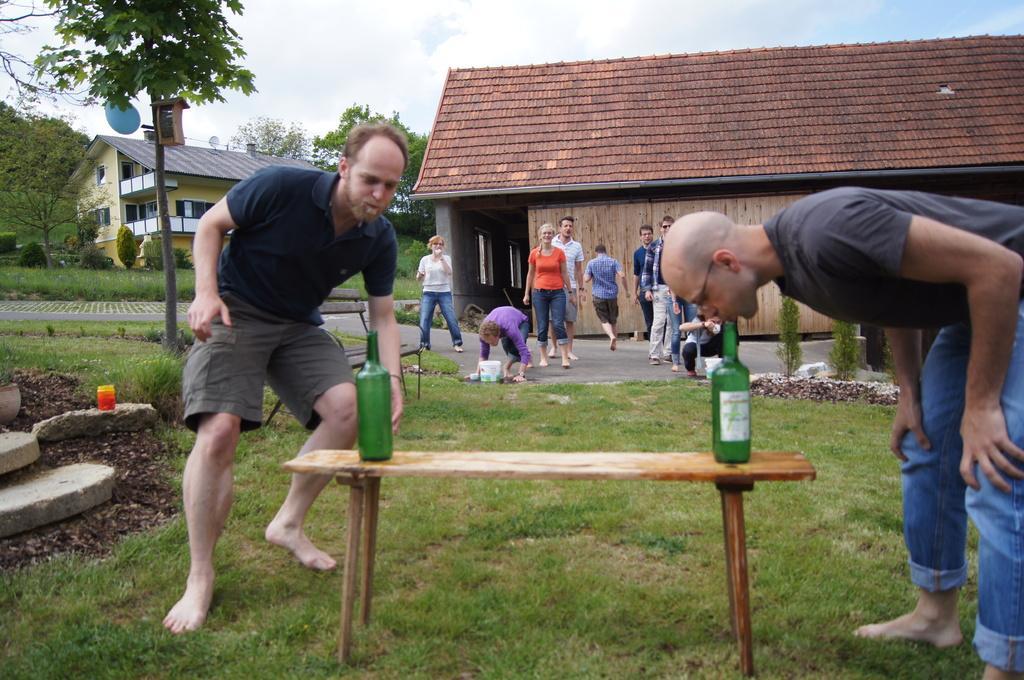In one or two sentences, can you explain what this image depicts? The picture is outside the house it looks like a lawn,there is a table, on the table to the both ends there are two bottles, behind the table there are some people standing,in the background there is a big house,to left that there are few trees and a sky. 